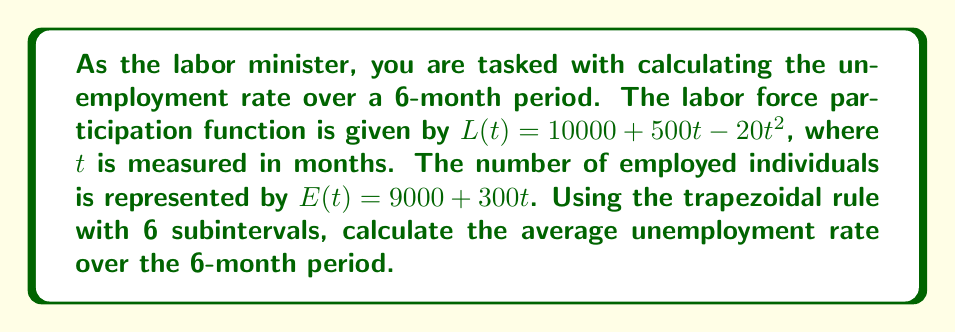Give your solution to this math problem. To solve this problem, we'll follow these steps:

1) The unemployment rate is given by:
   $U(t) = \frac{L(t) - E(t)}{L(t)} \times 100\%$

2) We need to calculate the average unemployment rate over 6 months:
   $\text{Average U} = \frac{1}{6} \int_0^6 U(t) dt$

3) We'll use the trapezoidal rule with 6 subintervals. The formula is:
   $$\int_a^b f(x) dx \approx \frac{h}{2}[f(x_0) + 2f(x_1) + 2f(x_2) + ... + 2f(x_{n-1}) + f(x_n)]$$
   where $h = \frac{b-a}{n}$, $n$ is the number of subintervals, and $x_i = a + ih$

4) In our case, $a=0$, $b=6$, $n=6$, so $h=1$

5) Calculate $U(t)$ for $t = 0, 1, 2, 3, 4, 5, 6$:

   $U(0) = \frac{10000 - 9000}{10000} \times 100\% = 10\%$
   $U(1) = \frac{(10480 - 9300)}{10480} \times 100\% \approx 11.26\%$
   $U(2) = \frac{(10920 - 9600)}{10920} \times 100\% \approx 12.09\%$
   $U(3) = \frac{(11320 - 9900)}{11320} \times 100\% \approx 12.54\%$
   $U(4) = \frac{(11680 - 10200)}{11680} \times 100\% \approx 12.67\%$
   $U(5) = \frac{(12000 - 10500)}{12000} \times 100\% \approx 12.50\%$
   $U(6) = \frac{(12280 - 10800)}{12280} \times 100\% \approx 12.05\%$

6) Apply the trapezoidal rule:
   $$\text{Average U} \approx \frac{1}{6} \cdot \frac{1}{2}[10 + 2(11.26 + 12.09 + 12.54 + 12.67 + 12.50) + 12.05]$$
   $$= \frac{1}{12}[10 + 122.12 + 12.05] = \frac{144.17}{12} \approx 12.01\%$$
Answer: 12.01% 